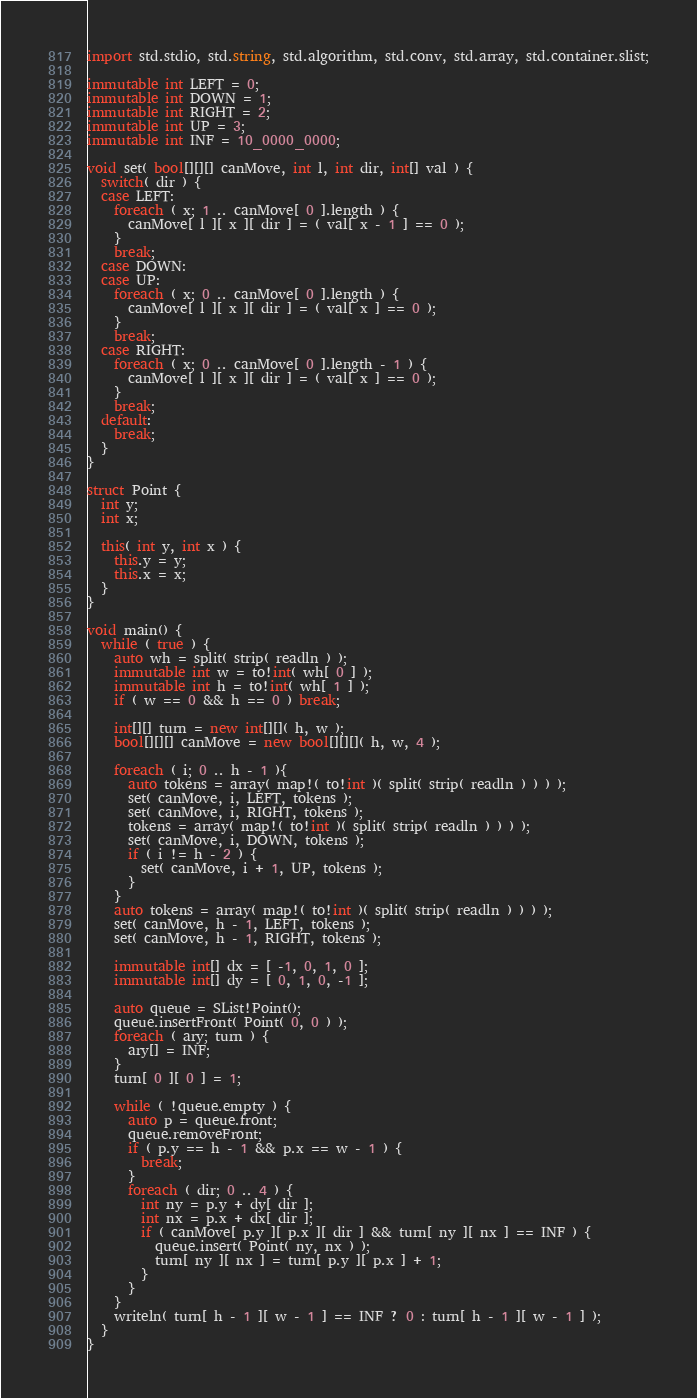<code> <loc_0><loc_0><loc_500><loc_500><_D_>import std.stdio, std.string, std.algorithm, std.conv, std.array, std.container.slist;

immutable int LEFT = 0;
immutable int DOWN = 1;
immutable int RIGHT = 2;
immutable int UP = 3;
immutable int INF = 10_0000_0000;

void set( bool[][][] canMove, int l, int dir, int[] val ) {
  switch( dir ) {
  case LEFT:
	foreach ( x; 1 .. canMove[ 0 ].length ) {
	  canMove[ l ][ x ][ dir ] = ( val[ x - 1 ] == 0 );
	}
	break;
  case DOWN:
  case UP:
	foreach ( x; 0 .. canMove[ 0 ].length ) {
	  canMove[ l ][ x ][ dir ] = ( val[ x ] == 0 );
	}
	break;
  case RIGHT:
	foreach ( x; 0 .. canMove[ 0 ].length - 1 ) {
	  canMove[ l ][ x ][ dir ] = ( val[ x ] == 0 );
	}
	break;
  default:
	break;
  }
}

struct Point {
  int y;
  int x;

  this( int y, int x ) {
	this.y = y;
	this.x = x;
  }
}

void main() {
  while ( true ) {
  	auto wh = split( strip( readln ) );
  	immutable int w = to!int( wh[ 0 ] );
  	immutable int h = to!int( wh[ 1 ] );
  	if ( w == 0 && h == 0 ) break;
	
	int[][] turn = new int[][]( h, w );
  	bool[][][] canMove = new bool[][][]( h, w, 4 );

	foreach ( i; 0 .. h - 1 ){
	  auto tokens = array( map!( to!int )( split( strip( readln ) ) ) );
	  set( canMove, i, LEFT, tokens );
	  set( canMove, i, RIGHT, tokens );
	  tokens = array( map!( to!int )( split( strip( readln ) ) ) );
	  set( canMove, i, DOWN, tokens );
	  if ( i != h - 2 ) {
		set( canMove, i + 1, UP, tokens );
	  }
  	}
	auto tokens = array( map!( to!int )( split( strip( readln ) ) ) );
	set( canMove, h - 1, LEFT, tokens );
	set( canMove, h - 1, RIGHT, tokens );
	
	immutable int[] dx = [ -1, 0, 1, 0 ];
  	immutable int[] dy = [ 0, 1, 0, -1 ];

	auto queue = SList!Point();
	queue.insertFront( Point( 0, 0 ) );
	foreach ( ary; turn ) {
	  ary[] = INF;
	}
	turn[ 0 ][ 0 ] = 1;
	
	while ( !queue.empty ) {
	  auto p = queue.front;
	  queue.removeFront;
	  if ( p.y == h - 1 && p.x == w - 1 ) {
		break;
	  }
	  foreach ( dir; 0 .. 4 ) {
		int ny = p.y + dy[ dir ];
		int nx = p.x + dx[ dir ];
		if ( canMove[ p.y ][ p.x ][ dir ] && turn[ ny ][ nx ] == INF ) {
		  queue.insert( Point( ny, nx ) );
		  turn[ ny ][ nx ] = turn[ p.y ][ p.x ] + 1;
		}
	  }
	}
	writeln( turn[ h - 1 ][ w - 1 ] == INF ? 0 : turn[ h - 1 ][ w - 1 ] );
  }
}</code> 